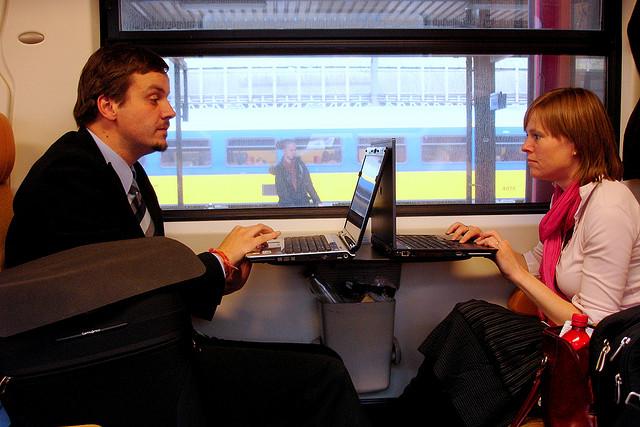Are the people talking to each other?
Be succinct. No. What color scarf is the woman wearing?
Concise answer only. Pink. Does he have down syndrome?
Give a very brief answer. No. Is the women wearing sunglasses?
Answer briefly. No. Is this man washing his hands?
Answer briefly. No. Are the two peoples knees touching?
Concise answer only. No. Where is the man's leg?
Write a very short answer. Under table. 